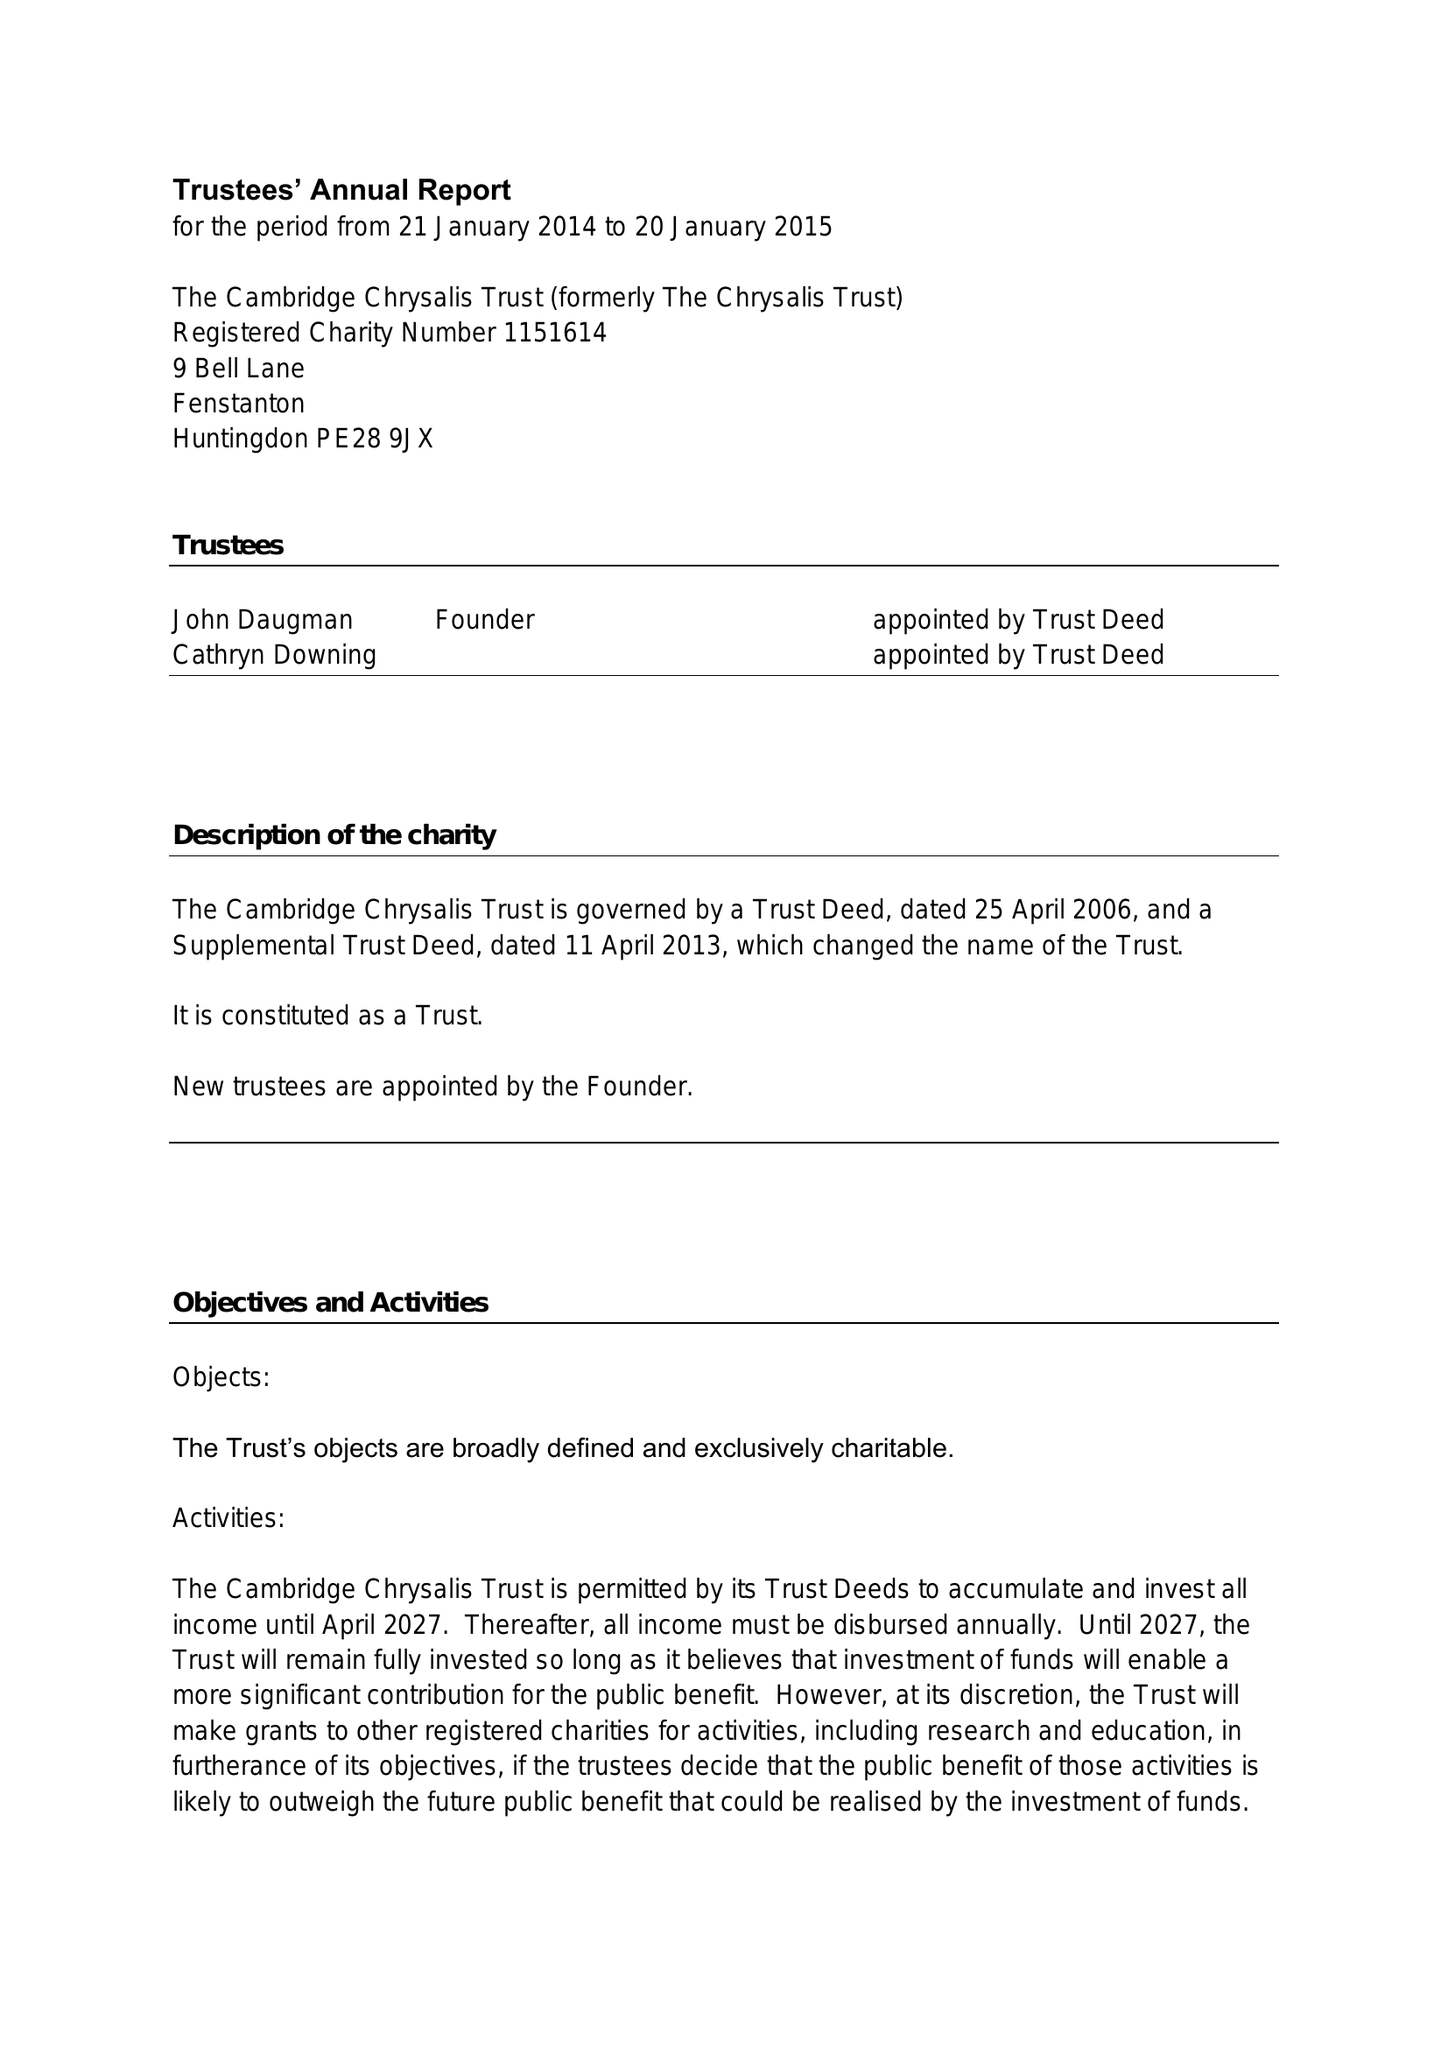What is the value for the charity_number?
Answer the question using a single word or phrase. 1151614 